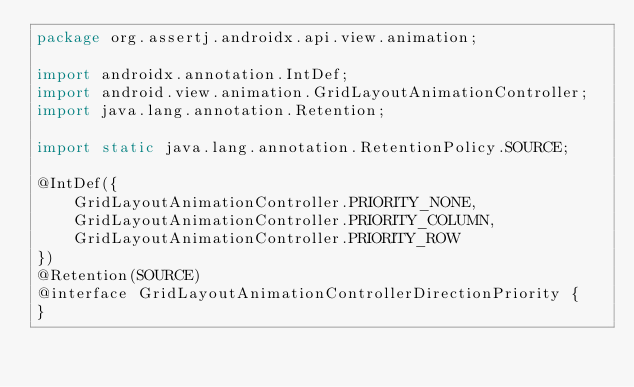<code> <loc_0><loc_0><loc_500><loc_500><_Java_>package org.assertj.androidx.api.view.animation;

import androidx.annotation.IntDef;
import android.view.animation.GridLayoutAnimationController;
import java.lang.annotation.Retention;

import static java.lang.annotation.RetentionPolicy.SOURCE;

@IntDef({
    GridLayoutAnimationController.PRIORITY_NONE,
    GridLayoutAnimationController.PRIORITY_COLUMN,
    GridLayoutAnimationController.PRIORITY_ROW
})
@Retention(SOURCE)
@interface GridLayoutAnimationControllerDirectionPriority {
}
</code> 